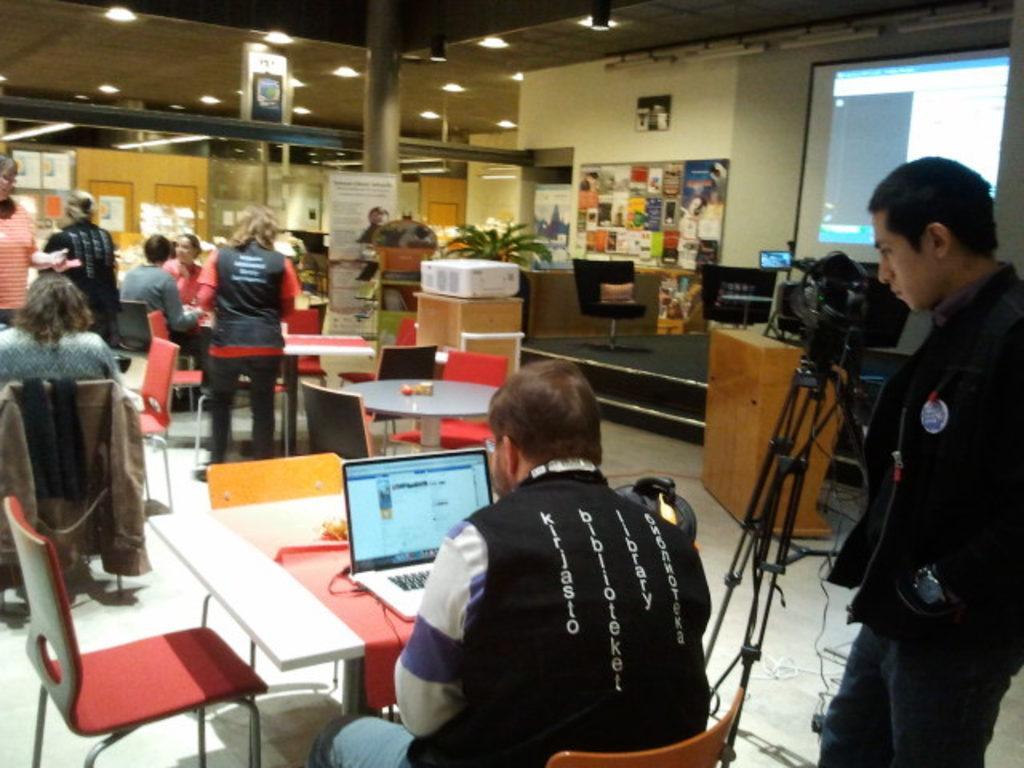How would you summarize this image in a sentence or two? In this image I can see number of people where few are sitting on chairs and rest all are standing. I can also see few empty chairs, few tables and on these tables I can see a laptop, a wire and few other things. On the right side of the image I can see a tripod stand, few wires and on the stand I can see a camera. In the background I can see two brown colour tables, a projector machine, number of boards, number of posters, a plant and on these boards I can see something is written. On the top side of the image I can see number of lights on the ceiling and on the top right side of the image I can see a projector screen. 